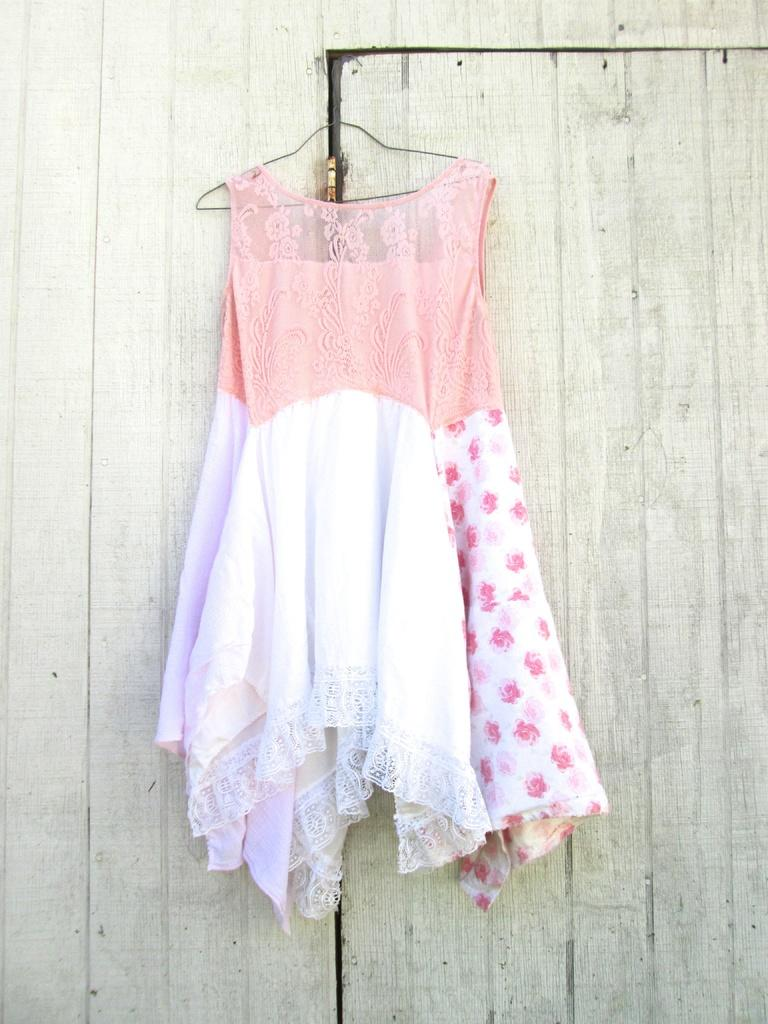What is located on the right side of the image? There is a door on the right side of the image. What object can be seen in the image that is typically used for hanging clothes? There is a hanger in the image. What type of garment is hanging on the hanger? There is a dress on the hanger. What type of rhythm can be heard coming from the dress in the image? There is no rhythm associated with the dress in the image, as it is a static object. Can you tell me what time it is according to the clock in the image? There is no clock present in the image. 